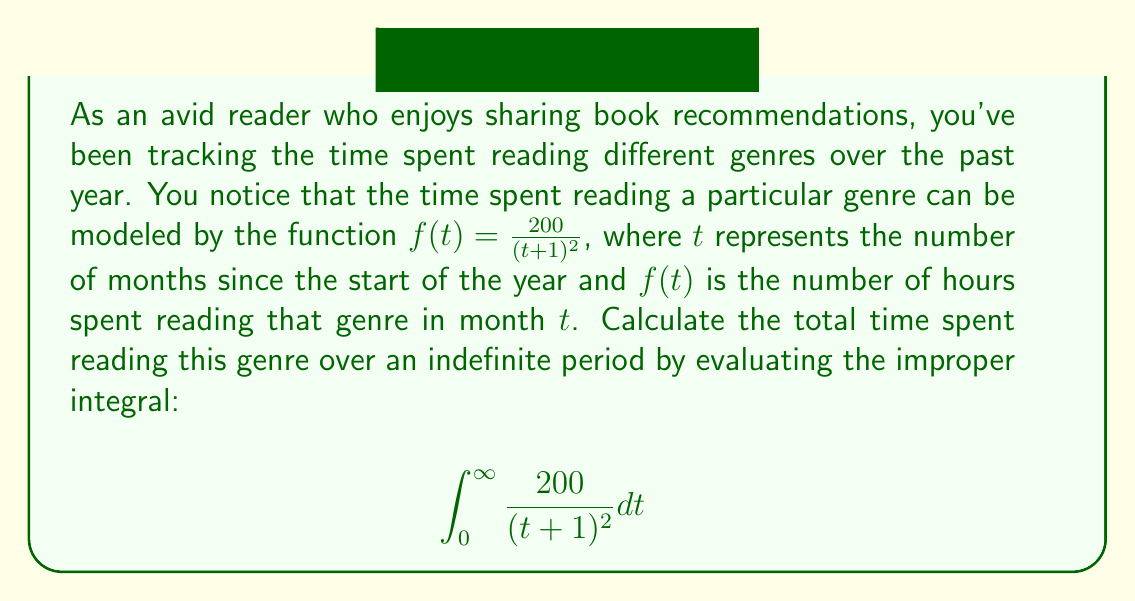Solve this math problem. Let's approach this step-by-step:

1) First, we recognize that this is an improper integral of the second kind, as the upper limit is infinity.

2) To evaluate this, we can use the limit definition of an improper integral:

   $$\int_0^\infty \frac{200}{(t+1)^2} dt = \lim_{b \to \infty} \int_0^b \frac{200}{(t+1)^2} dt$$

3) Now, let's solve the definite integral:
   
   $$\int \frac{200}{(t+1)^2} dt = -\frac{200}{t+1} + C$$

4) Applying the limits:

   $$\lim_{b \to \infty} \left[-\frac{200}{t+1}\right]_0^b = \lim_{b \to \infty} \left(-\frac{200}{b+1} + \frac{200}{0+1}\right)$$

5) Simplify:

   $$= \lim_{b \to \infty} \left(-\frac{200}{b+1} + 200\right)$$

6) As $b$ approaches infinity, $\frac{200}{b+1}$ approaches 0:

   $$= 0 + 200 = 200$$

Therefore, the total time spent reading this genre over an indefinite period is 200 hours.
Answer: 200 hours 